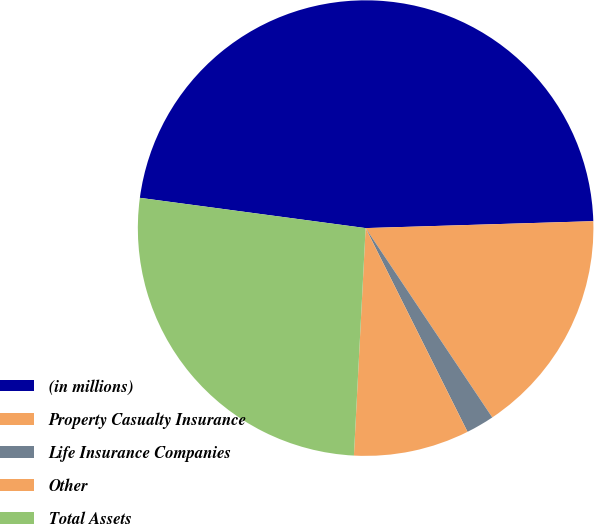Convert chart. <chart><loc_0><loc_0><loc_500><loc_500><pie_chart><fcel>(in millions)<fcel>Property Casualty Insurance<fcel>Life Insurance Companies<fcel>Other<fcel>Total Assets<nl><fcel>47.39%<fcel>16.1%<fcel>2.0%<fcel>8.2%<fcel>26.3%<nl></chart> 